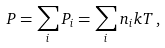Convert formula to latex. <formula><loc_0><loc_0><loc_500><loc_500>P = \sum _ { i } P _ { i } = \sum _ { i } n _ { i } k T \, ,</formula> 